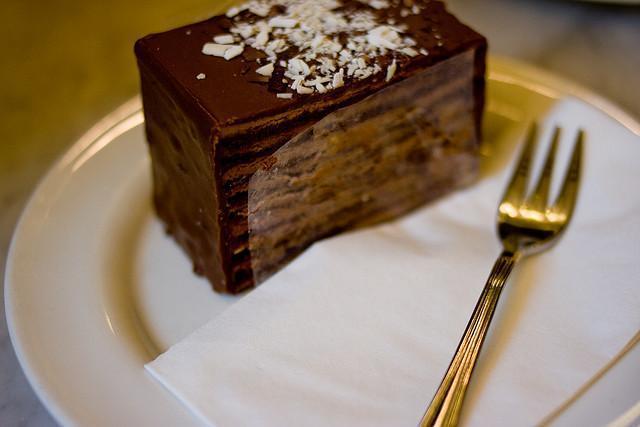How many people can eat this cake?
Give a very brief answer. 1. How many clocks do you see?
Give a very brief answer. 0. 